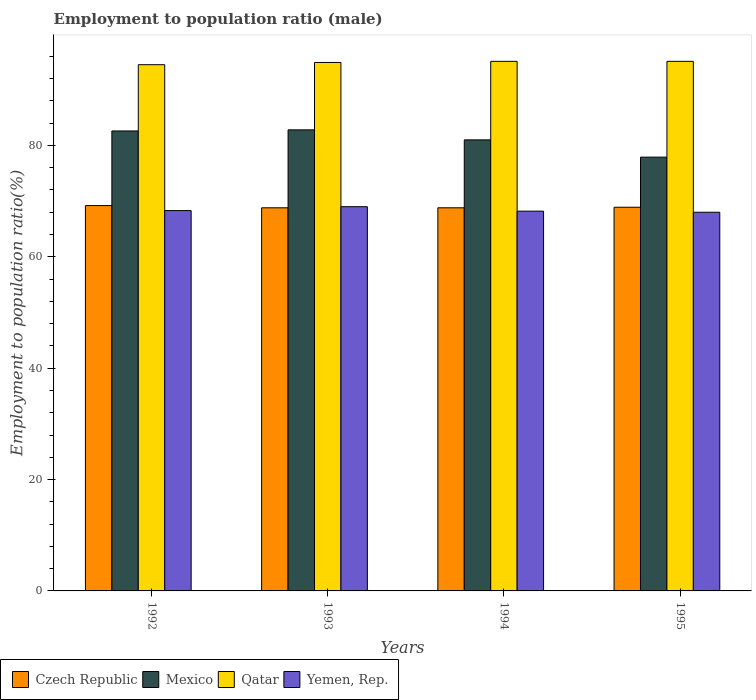How many different coloured bars are there?
Your response must be concise. 4. How many groups of bars are there?
Provide a succinct answer. 4. Are the number of bars per tick equal to the number of legend labels?
Keep it short and to the point. Yes. Are the number of bars on each tick of the X-axis equal?
Provide a succinct answer. Yes. In how many cases, is the number of bars for a given year not equal to the number of legend labels?
Give a very brief answer. 0. What is the employment to population ratio in Yemen, Rep. in 1993?
Ensure brevity in your answer.  69. Across all years, what is the maximum employment to population ratio in Yemen, Rep.?
Give a very brief answer. 69. Across all years, what is the minimum employment to population ratio in Yemen, Rep.?
Provide a short and direct response. 68. In which year was the employment to population ratio in Qatar maximum?
Your response must be concise. 1994. What is the total employment to population ratio in Yemen, Rep. in the graph?
Offer a very short reply. 273.5. What is the difference between the employment to population ratio in Mexico in 1992 and that in 1993?
Make the answer very short. -0.2. What is the difference between the employment to population ratio in Czech Republic in 1994 and the employment to population ratio in Mexico in 1995?
Keep it short and to the point. -9.1. What is the average employment to population ratio in Yemen, Rep. per year?
Offer a terse response. 68.38. In the year 1993, what is the difference between the employment to population ratio in Yemen, Rep. and employment to population ratio in Mexico?
Your response must be concise. -13.8. In how many years, is the employment to population ratio in Mexico greater than 56 %?
Offer a terse response. 4. What is the ratio of the employment to population ratio in Mexico in 1994 to that in 1995?
Provide a succinct answer. 1.04. Is the employment to population ratio in Mexico in 1994 less than that in 1995?
Offer a terse response. No. What is the difference between the highest and the second highest employment to population ratio in Mexico?
Your answer should be compact. 0.2. What is the difference between the highest and the lowest employment to population ratio in Czech Republic?
Your answer should be very brief. 0.4. In how many years, is the employment to population ratio in Qatar greater than the average employment to population ratio in Qatar taken over all years?
Your answer should be compact. 3. Is the sum of the employment to population ratio in Czech Republic in 1993 and 1995 greater than the maximum employment to population ratio in Mexico across all years?
Ensure brevity in your answer.  Yes. What does the 2nd bar from the left in 1994 represents?
Provide a succinct answer. Mexico. What does the 1st bar from the right in 1992 represents?
Your response must be concise. Yemen, Rep. How many bars are there?
Your answer should be compact. 16. Are all the bars in the graph horizontal?
Your answer should be compact. No. How many years are there in the graph?
Your answer should be very brief. 4. Are the values on the major ticks of Y-axis written in scientific E-notation?
Ensure brevity in your answer.  No. Where does the legend appear in the graph?
Keep it short and to the point. Bottom left. What is the title of the graph?
Offer a very short reply. Employment to population ratio (male). Does "Mali" appear as one of the legend labels in the graph?
Keep it short and to the point. No. What is the label or title of the Y-axis?
Make the answer very short. Employment to population ratio(%). What is the Employment to population ratio(%) of Czech Republic in 1992?
Keep it short and to the point. 69.2. What is the Employment to population ratio(%) in Mexico in 1992?
Offer a terse response. 82.6. What is the Employment to population ratio(%) in Qatar in 1992?
Keep it short and to the point. 94.5. What is the Employment to population ratio(%) of Yemen, Rep. in 1992?
Offer a very short reply. 68.3. What is the Employment to population ratio(%) of Czech Republic in 1993?
Provide a succinct answer. 68.8. What is the Employment to population ratio(%) in Mexico in 1993?
Provide a succinct answer. 82.8. What is the Employment to population ratio(%) in Qatar in 1993?
Give a very brief answer. 94.9. What is the Employment to population ratio(%) of Czech Republic in 1994?
Give a very brief answer. 68.8. What is the Employment to population ratio(%) of Mexico in 1994?
Offer a terse response. 81. What is the Employment to population ratio(%) in Qatar in 1994?
Give a very brief answer. 95.1. What is the Employment to population ratio(%) of Yemen, Rep. in 1994?
Ensure brevity in your answer.  68.2. What is the Employment to population ratio(%) of Czech Republic in 1995?
Ensure brevity in your answer.  68.9. What is the Employment to population ratio(%) of Mexico in 1995?
Offer a terse response. 77.9. What is the Employment to population ratio(%) of Qatar in 1995?
Your answer should be very brief. 95.1. Across all years, what is the maximum Employment to population ratio(%) of Czech Republic?
Make the answer very short. 69.2. Across all years, what is the maximum Employment to population ratio(%) in Mexico?
Keep it short and to the point. 82.8. Across all years, what is the maximum Employment to population ratio(%) of Qatar?
Give a very brief answer. 95.1. Across all years, what is the minimum Employment to population ratio(%) of Czech Republic?
Your answer should be compact. 68.8. Across all years, what is the minimum Employment to population ratio(%) of Mexico?
Offer a very short reply. 77.9. Across all years, what is the minimum Employment to population ratio(%) in Qatar?
Keep it short and to the point. 94.5. What is the total Employment to population ratio(%) of Czech Republic in the graph?
Your answer should be very brief. 275.7. What is the total Employment to population ratio(%) in Mexico in the graph?
Make the answer very short. 324.3. What is the total Employment to population ratio(%) in Qatar in the graph?
Offer a terse response. 379.6. What is the total Employment to population ratio(%) in Yemen, Rep. in the graph?
Offer a very short reply. 273.5. What is the difference between the Employment to population ratio(%) of Mexico in 1992 and that in 1993?
Offer a terse response. -0.2. What is the difference between the Employment to population ratio(%) of Qatar in 1992 and that in 1993?
Keep it short and to the point. -0.4. What is the difference between the Employment to population ratio(%) of Qatar in 1992 and that in 1994?
Provide a short and direct response. -0.6. What is the difference between the Employment to population ratio(%) in Yemen, Rep. in 1992 and that in 1994?
Offer a very short reply. 0.1. What is the difference between the Employment to population ratio(%) in Mexico in 1992 and that in 1995?
Keep it short and to the point. 4.7. What is the difference between the Employment to population ratio(%) in Qatar in 1992 and that in 1995?
Offer a very short reply. -0.6. What is the difference between the Employment to population ratio(%) in Yemen, Rep. in 1992 and that in 1995?
Provide a short and direct response. 0.3. What is the difference between the Employment to population ratio(%) of Mexico in 1993 and that in 1994?
Your answer should be very brief. 1.8. What is the difference between the Employment to population ratio(%) in Qatar in 1993 and that in 1994?
Provide a succinct answer. -0.2. What is the difference between the Employment to population ratio(%) of Yemen, Rep. in 1993 and that in 1994?
Provide a short and direct response. 0.8. What is the difference between the Employment to population ratio(%) in Qatar in 1993 and that in 1995?
Your response must be concise. -0.2. What is the difference between the Employment to population ratio(%) of Mexico in 1994 and that in 1995?
Your answer should be very brief. 3.1. What is the difference between the Employment to population ratio(%) in Czech Republic in 1992 and the Employment to population ratio(%) in Qatar in 1993?
Provide a succinct answer. -25.7. What is the difference between the Employment to population ratio(%) of Mexico in 1992 and the Employment to population ratio(%) of Yemen, Rep. in 1993?
Provide a short and direct response. 13.6. What is the difference between the Employment to population ratio(%) of Czech Republic in 1992 and the Employment to population ratio(%) of Qatar in 1994?
Your response must be concise. -25.9. What is the difference between the Employment to population ratio(%) of Mexico in 1992 and the Employment to population ratio(%) of Qatar in 1994?
Provide a succinct answer. -12.5. What is the difference between the Employment to population ratio(%) of Mexico in 1992 and the Employment to population ratio(%) of Yemen, Rep. in 1994?
Ensure brevity in your answer.  14.4. What is the difference between the Employment to population ratio(%) of Qatar in 1992 and the Employment to population ratio(%) of Yemen, Rep. in 1994?
Ensure brevity in your answer.  26.3. What is the difference between the Employment to population ratio(%) of Czech Republic in 1992 and the Employment to population ratio(%) of Qatar in 1995?
Offer a terse response. -25.9. What is the difference between the Employment to population ratio(%) of Czech Republic in 1992 and the Employment to population ratio(%) of Yemen, Rep. in 1995?
Provide a succinct answer. 1.2. What is the difference between the Employment to population ratio(%) of Mexico in 1992 and the Employment to population ratio(%) of Qatar in 1995?
Your response must be concise. -12.5. What is the difference between the Employment to population ratio(%) of Czech Republic in 1993 and the Employment to population ratio(%) of Mexico in 1994?
Provide a succinct answer. -12.2. What is the difference between the Employment to population ratio(%) of Czech Republic in 1993 and the Employment to population ratio(%) of Qatar in 1994?
Offer a terse response. -26.3. What is the difference between the Employment to population ratio(%) of Czech Republic in 1993 and the Employment to population ratio(%) of Yemen, Rep. in 1994?
Your response must be concise. 0.6. What is the difference between the Employment to population ratio(%) in Qatar in 1993 and the Employment to population ratio(%) in Yemen, Rep. in 1994?
Provide a short and direct response. 26.7. What is the difference between the Employment to population ratio(%) of Czech Republic in 1993 and the Employment to population ratio(%) of Mexico in 1995?
Make the answer very short. -9.1. What is the difference between the Employment to population ratio(%) in Czech Republic in 1993 and the Employment to population ratio(%) in Qatar in 1995?
Your response must be concise. -26.3. What is the difference between the Employment to population ratio(%) of Czech Republic in 1993 and the Employment to population ratio(%) of Yemen, Rep. in 1995?
Your answer should be compact. 0.8. What is the difference between the Employment to population ratio(%) of Mexico in 1993 and the Employment to population ratio(%) of Qatar in 1995?
Provide a succinct answer. -12.3. What is the difference between the Employment to population ratio(%) in Qatar in 1993 and the Employment to population ratio(%) in Yemen, Rep. in 1995?
Provide a succinct answer. 26.9. What is the difference between the Employment to population ratio(%) in Czech Republic in 1994 and the Employment to population ratio(%) in Mexico in 1995?
Your response must be concise. -9.1. What is the difference between the Employment to population ratio(%) in Czech Republic in 1994 and the Employment to population ratio(%) in Qatar in 1995?
Make the answer very short. -26.3. What is the difference between the Employment to population ratio(%) in Mexico in 1994 and the Employment to population ratio(%) in Qatar in 1995?
Your answer should be very brief. -14.1. What is the difference between the Employment to population ratio(%) of Mexico in 1994 and the Employment to population ratio(%) of Yemen, Rep. in 1995?
Ensure brevity in your answer.  13. What is the difference between the Employment to population ratio(%) of Qatar in 1994 and the Employment to population ratio(%) of Yemen, Rep. in 1995?
Give a very brief answer. 27.1. What is the average Employment to population ratio(%) in Czech Republic per year?
Offer a terse response. 68.92. What is the average Employment to population ratio(%) of Mexico per year?
Ensure brevity in your answer.  81.08. What is the average Employment to population ratio(%) of Qatar per year?
Offer a very short reply. 94.9. What is the average Employment to population ratio(%) in Yemen, Rep. per year?
Your answer should be very brief. 68.38. In the year 1992, what is the difference between the Employment to population ratio(%) in Czech Republic and Employment to population ratio(%) in Qatar?
Offer a terse response. -25.3. In the year 1992, what is the difference between the Employment to population ratio(%) of Czech Republic and Employment to population ratio(%) of Yemen, Rep.?
Your response must be concise. 0.9. In the year 1992, what is the difference between the Employment to population ratio(%) of Mexico and Employment to population ratio(%) of Qatar?
Ensure brevity in your answer.  -11.9. In the year 1992, what is the difference between the Employment to population ratio(%) of Mexico and Employment to population ratio(%) of Yemen, Rep.?
Keep it short and to the point. 14.3. In the year 1992, what is the difference between the Employment to population ratio(%) in Qatar and Employment to population ratio(%) in Yemen, Rep.?
Provide a short and direct response. 26.2. In the year 1993, what is the difference between the Employment to population ratio(%) in Czech Republic and Employment to population ratio(%) in Mexico?
Offer a terse response. -14. In the year 1993, what is the difference between the Employment to population ratio(%) of Czech Republic and Employment to population ratio(%) of Qatar?
Give a very brief answer. -26.1. In the year 1993, what is the difference between the Employment to population ratio(%) in Mexico and Employment to population ratio(%) in Yemen, Rep.?
Keep it short and to the point. 13.8. In the year 1993, what is the difference between the Employment to population ratio(%) of Qatar and Employment to population ratio(%) of Yemen, Rep.?
Ensure brevity in your answer.  25.9. In the year 1994, what is the difference between the Employment to population ratio(%) of Czech Republic and Employment to population ratio(%) of Mexico?
Your answer should be very brief. -12.2. In the year 1994, what is the difference between the Employment to population ratio(%) of Czech Republic and Employment to population ratio(%) of Qatar?
Keep it short and to the point. -26.3. In the year 1994, what is the difference between the Employment to population ratio(%) of Czech Republic and Employment to population ratio(%) of Yemen, Rep.?
Offer a very short reply. 0.6. In the year 1994, what is the difference between the Employment to population ratio(%) in Mexico and Employment to population ratio(%) in Qatar?
Offer a very short reply. -14.1. In the year 1994, what is the difference between the Employment to population ratio(%) in Mexico and Employment to population ratio(%) in Yemen, Rep.?
Your answer should be compact. 12.8. In the year 1994, what is the difference between the Employment to population ratio(%) in Qatar and Employment to population ratio(%) in Yemen, Rep.?
Offer a very short reply. 26.9. In the year 1995, what is the difference between the Employment to population ratio(%) of Czech Republic and Employment to population ratio(%) of Qatar?
Provide a succinct answer. -26.2. In the year 1995, what is the difference between the Employment to population ratio(%) of Czech Republic and Employment to population ratio(%) of Yemen, Rep.?
Offer a very short reply. 0.9. In the year 1995, what is the difference between the Employment to population ratio(%) in Mexico and Employment to population ratio(%) in Qatar?
Ensure brevity in your answer.  -17.2. In the year 1995, what is the difference between the Employment to population ratio(%) in Qatar and Employment to population ratio(%) in Yemen, Rep.?
Your answer should be compact. 27.1. What is the ratio of the Employment to population ratio(%) in Czech Republic in 1992 to that in 1993?
Provide a succinct answer. 1.01. What is the ratio of the Employment to population ratio(%) of Yemen, Rep. in 1992 to that in 1993?
Provide a succinct answer. 0.99. What is the ratio of the Employment to population ratio(%) in Czech Republic in 1992 to that in 1994?
Make the answer very short. 1.01. What is the ratio of the Employment to population ratio(%) in Mexico in 1992 to that in 1994?
Your answer should be compact. 1.02. What is the ratio of the Employment to population ratio(%) in Qatar in 1992 to that in 1994?
Give a very brief answer. 0.99. What is the ratio of the Employment to population ratio(%) of Yemen, Rep. in 1992 to that in 1994?
Offer a very short reply. 1. What is the ratio of the Employment to population ratio(%) in Mexico in 1992 to that in 1995?
Offer a very short reply. 1.06. What is the ratio of the Employment to population ratio(%) in Yemen, Rep. in 1992 to that in 1995?
Make the answer very short. 1. What is the ratio of the Employment to population ratio(%) of Czech Republic in 1993 to that in 1994?
Offer a very short reply. 1. What is the ratio of the Employment to population ratio(%) in Mexico in 1993 to that in 1994?
Ensure brevity in your answer.  1.02. What is the ratio of the Employment to population ratio(%) of Yemen, Rep. in 1993 to that in 1994?
Your answer should be very brief. 1.01. What is the ratio of the Employment to population ratio(%) in Czech Republic in 1993 to that in 1995?
Your response must be concise. 1. What is the ratio of the Employment to population ratio(%) in Mexico in 1993 to that in 1995?
Offer a terse response. 1.06. What is the ratio of the Employment to population ratio(%) in Yemen, Rep. in 1993 to that in 1995?
Make the answer very short. 1.01. What is the ratio of the Employment to population ratio(%) in Mexico in 1994 to that in 1995?
Offer a terse response. 1.04. What is the ratio of the Employment to population ratio(%) in Qatar in 1994 to that in 1995?
Give a very brief answer. 1. What is the difference between the highest and the second highest Employment to population ratio(%) in Czech Republic?
Offer a terse response. 0.3. What is the difference between the highest and the second highest Employment to population ratio(%) in Mexico?
Provide a short and direct response. 0.2. What is the difference between the highest and the second highest Employment to population ratio(%) in Yemen, Rep.?
Offer a very short reply. 0.7. What is the difference between the highest and the lowest Employment to population ratio(%) in Czech Republic?
Give a very brief answer. 0.4. What is the difference between the highest and the lowest Employment to population ratio(%) in Qatar?
Provide a short and direct response. 0.6. 